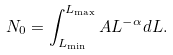Convert formula to latex. <formula><loc_0><loc_0><loc_500><loc_500>N _ { 0 } = \int _ { L _ { \min } } ^ { L _ { \max } } A L ^ { - \alpha } d L .</formula> 